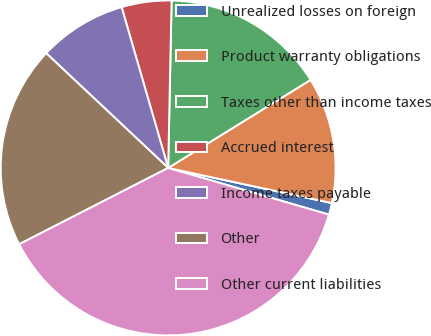<chart> <loc_0><loc_0><loc_500><loc_500><pie_chart><fcel>Unrealized losses on foreign<fcel>Product warranty obligations<fcel>Taxes other than income taxes<fcel>Accrued interest<fcel>Income taxes payable<fcel>Other<fcel>Other current liabilities<nl><fcel>1.13%<fcel>12.18%<fcel>15.86%<fcel>4.81%<fcel>8.5%<fcel>19.55%<fcel>37.97%<nl></chart> 